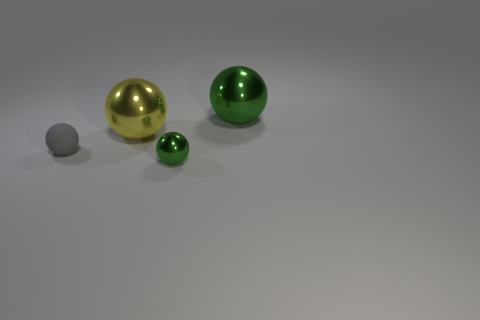What size is the green metallic object in front of the green metallic thing to the right of the tiny green metallic object to the left of the big green ball?
Your answer should be very brief. Small. What size is the yellow sphere?
Your answer should be compact. Large. Is there any other thing that has the same material as the yellow object?
Your answer should be very brief. Yes. Is there a green metallic sphere in front of the large object on the right side of the object in front of the gray rubber ball?
Provide a short and direct response. Yes. How many tiny objects are either shiny objects or balls?
Make the answer very short. 2. Are there any other things of the same color as the small rubber ball?
Provide a short and direct response. No. Is the size of the green shiny ball that is behind the gray rubber ball the same as the tiny matte ball?
Your answer should be very brief. No. What is the color of the sphere to the right of the green metallic ball in front of the yellow metallic object that is right of the gray rubber object?
Your response must be concise. Green. The rubber object is what color?
Give a very brief answer. Gray. Is the color of the small shiny thing the same as the small matte sphere?
Your response must be concise. No. 